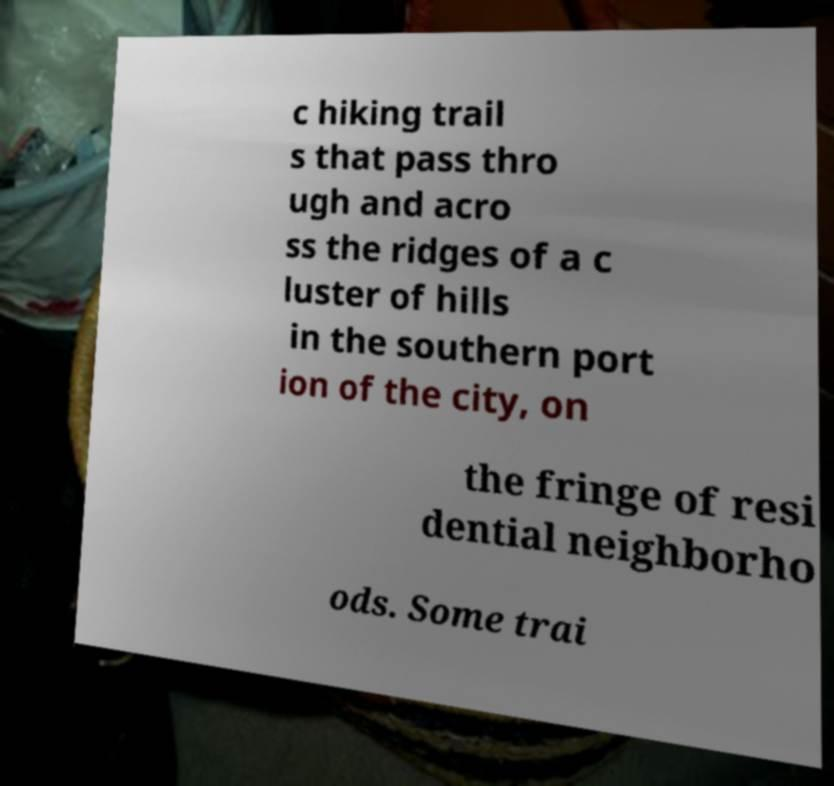Could you extract and type out the text from this image? c hiking trail s that pass thro ugh and acro ss the ridges of a c luster of hills in the southern port ion of the city, on the fringe of resi dential neighborho ods. Some trai 